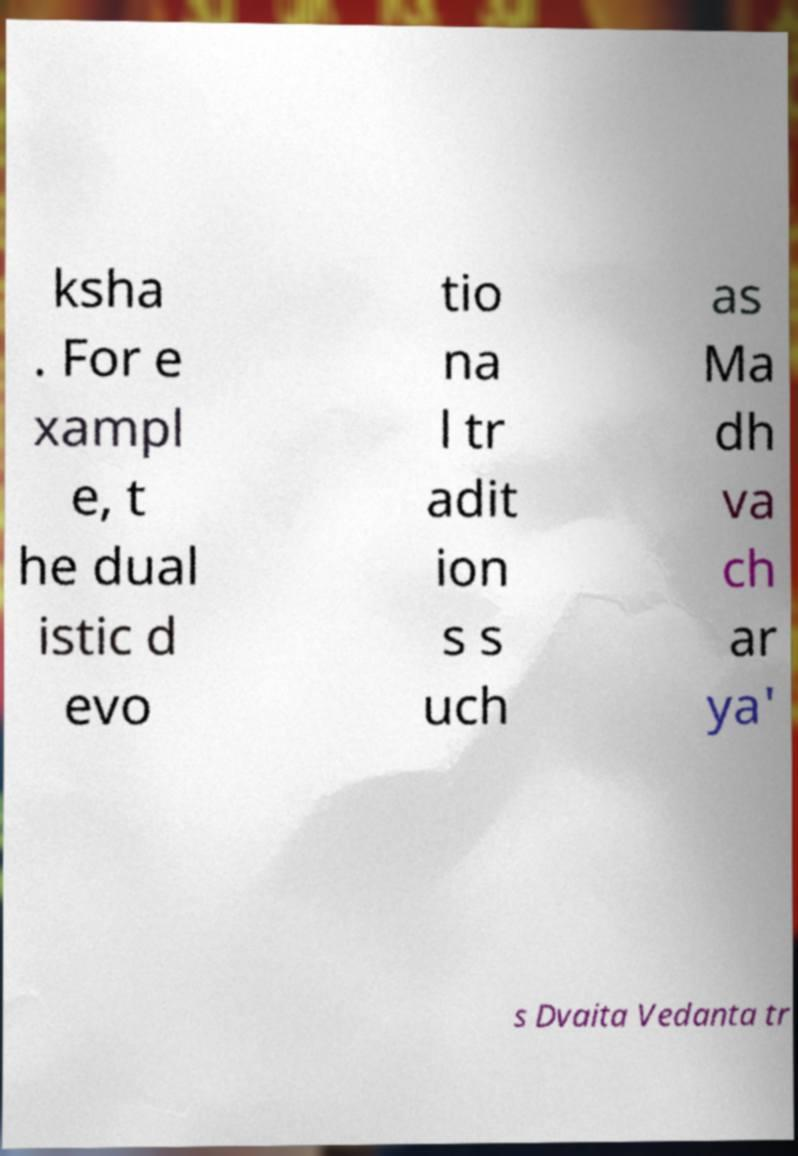Please identify and transcribe the text found in this image. ksha . For e xampl e, t he dual istic d evo tio na l tr adit ion s s uch as Ma dh va ch ar ya' s Dvaita Vedanta tr 